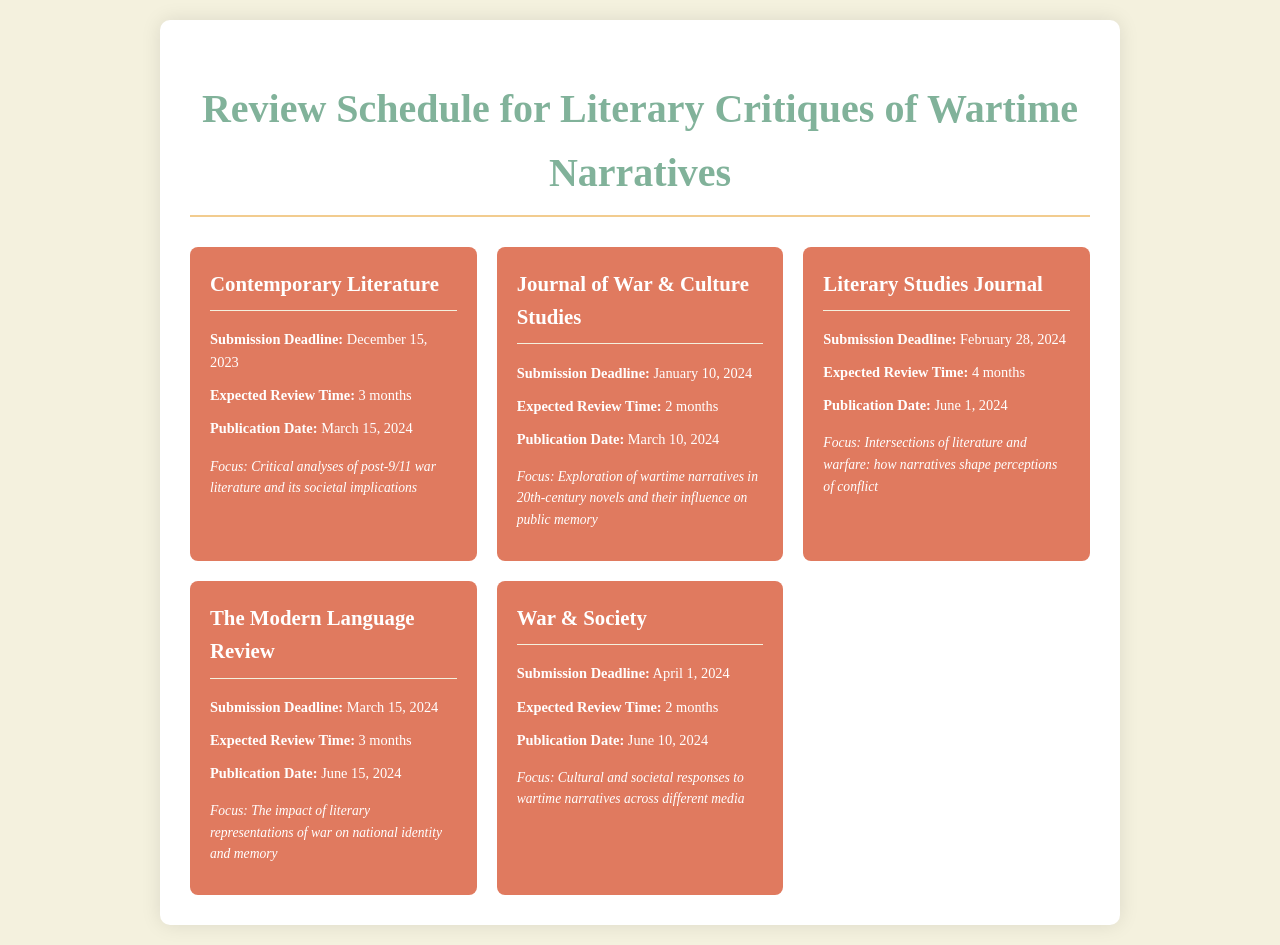What is the submission deadline for Contemporary Literature? The submission deadline for Contemporary Literature is specifically mentioned in the document as December 15, 2023.
Answer: December 15, 2023 How long is the expected review time for the Journal of War & Culture Studies? The document states that the expected review time for the Journal of War & Culture Studies is 2 months.
Answer: 2 months What is the publication date for Literary Studies Journal? The document indicates that the publication date for Literary Studies Journal is June 1, 2024.
Answer: June 1, 2024 What is the focus of The Modern Language Review? The document describes the focus of The Modern Language Review as the impact of literary representations of war on national identity and memory.
Answer: The impact of literary representations of war on national identity and memory Which journal has a submission deadline of April 1, 2024? The document lists War & Society with a submission deadline of April 1, 2024.
Answer: War & Society What is the expected review time for Contemporary Literature in months? The expected review time for Contemporary Literature is explicitly mentioned as 3 months in the document.
Answer: 3 months Which journal focuses on critical analyses of post-9/11 war literature? The document specifies that Contemporary Literature focuses on critical analyses of post-9/11 war literature and its societal implications.
Answer: Contemporary Literature When is the publication date for the Journal of War & Culture Studies? The document specifies that the publication date for the Journal of War & Culture Studies is March 10, 2024.
Answer: March 10, 2024 